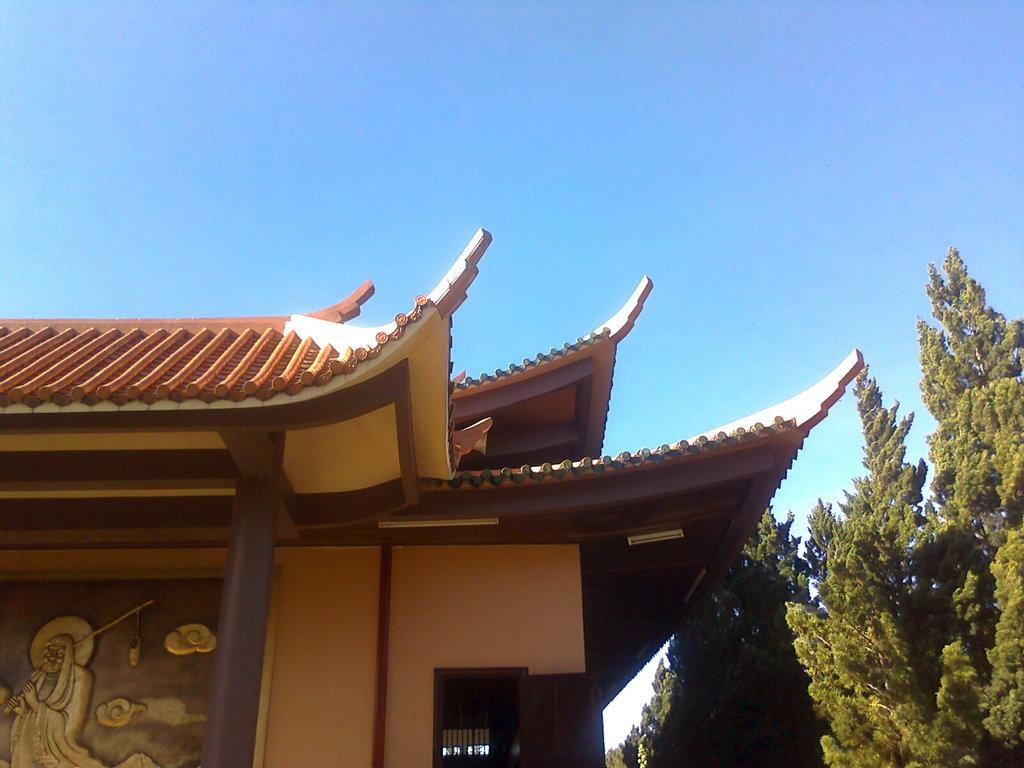What structure is located on the left side of the image? There is a house on the left side of the image. What type of vegetation is on the right side of the image? There are trees on the right side of the image. What color is the sky in the image? The sky is blue in the image. Can you tell me how many beasts are depicted in the image? There are no beasts present in the image; it features a house and trees. What type of club is being used in the image? There is no club present in the image. 